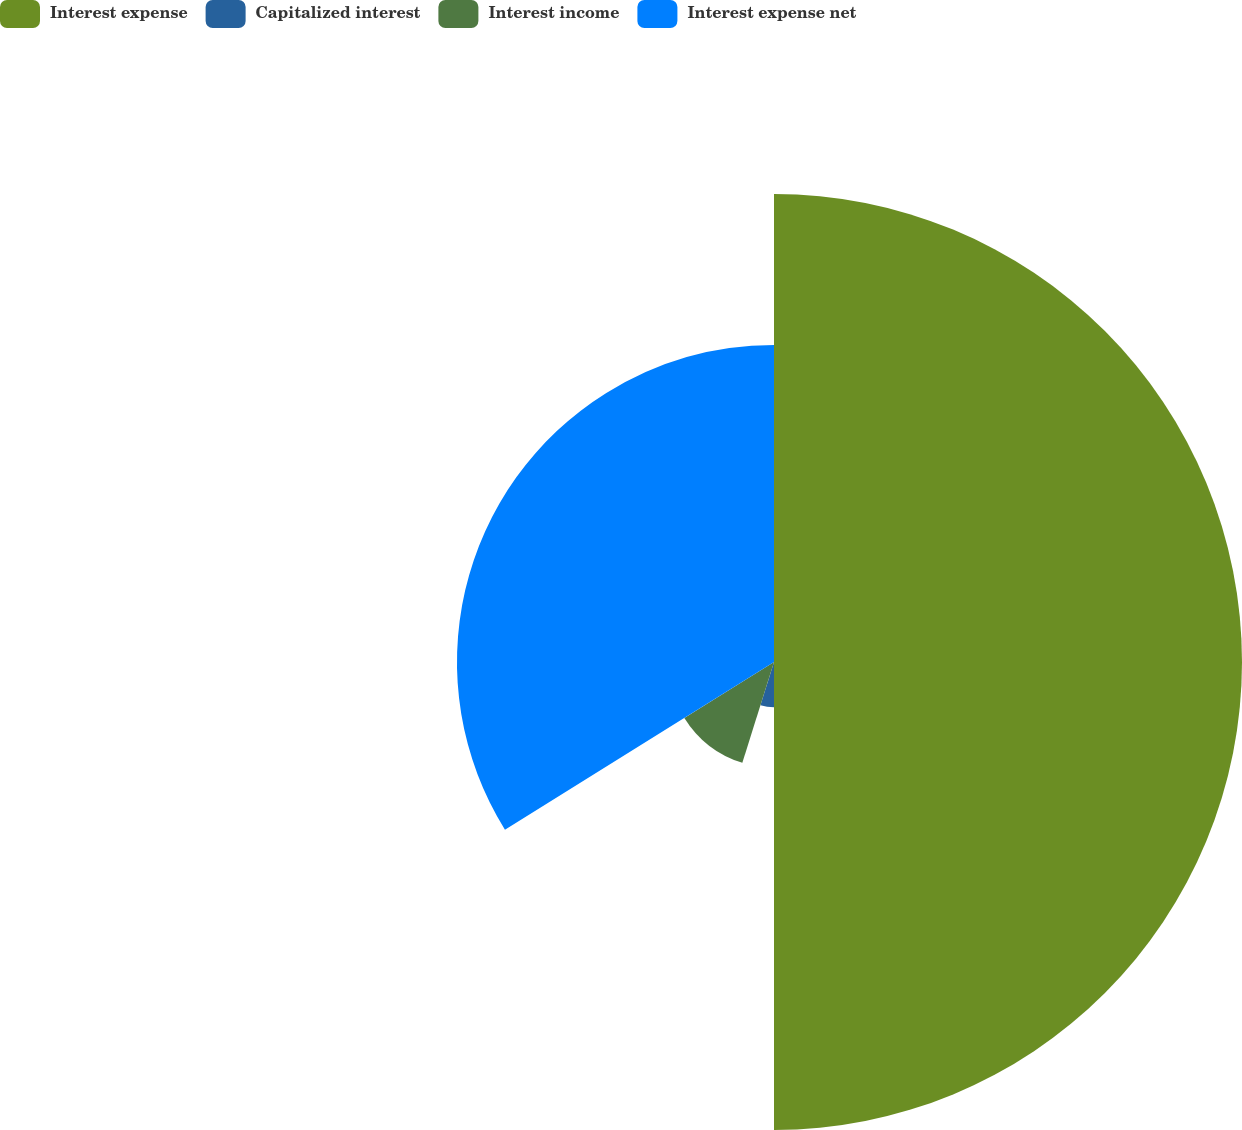Convert chart. <chart><loc_0><loc_0><loc_500><loc_500><pie_chart><fcel>Interest expense<fcel>Capitalized interest<fcel>Interest income<fcel>Interest expense net<nl><fcel>50.0%<fcel>4.84%<fcel>11.29%<fcel>33.87%<nl></chart> 